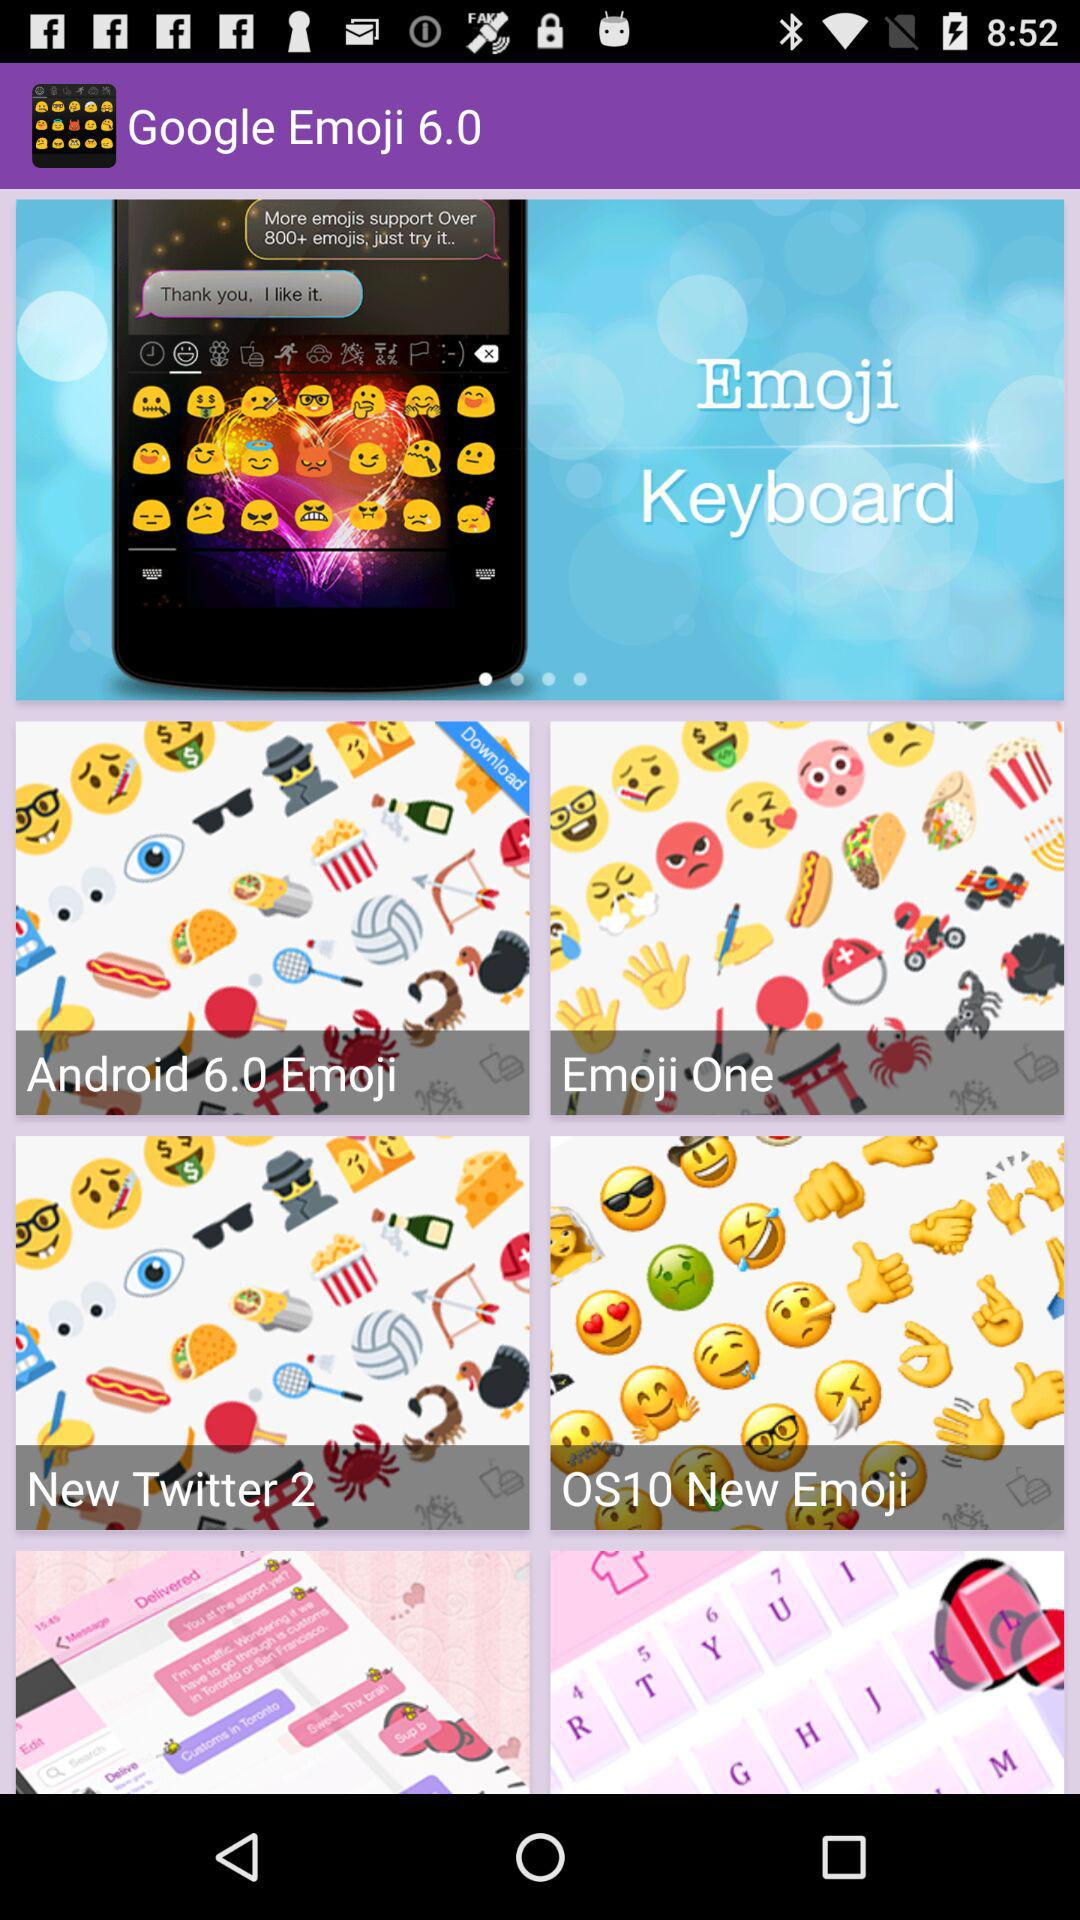In which version of android, different emojis are introduced?
When the provided information is insufficient, respond with <no answer>. <no answer> 